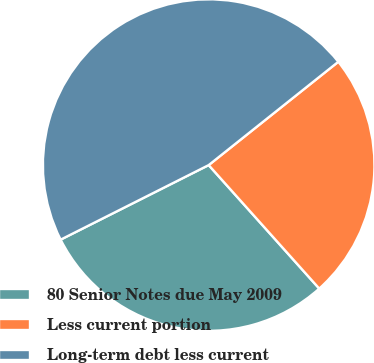Convert chart. <chart><loc_0><loc_0><loc_500><loc_500><pie_chart><fcel>80 Senior Notes due May 2009<fcel>Less current portion<fcel>Long-term debt less current<nl><fcel>29.2%<fcel>24.09%<fcel>46.72%<nl></chart> 